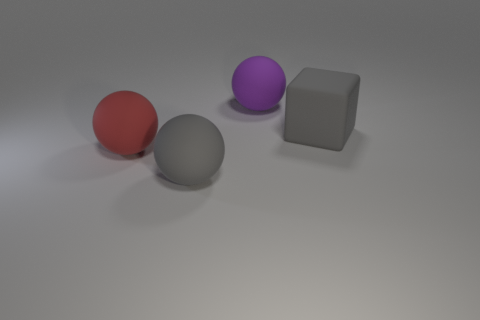What number of gray matte things have the same shape as the big red thing?
Ensure brevity in your answer.  1. The big red object is what shape?
Your answer should be very brief. Sphere. What is the size of the red ball left of the big gray matte object that is behind the big red rubber thing?
Give a very brief answer. Large. What number of things are either gray shiny cylinders or purple balls?
Ensure brevity in your answer.  1. Is the red rubber object the same shape as the large purple object?
Your response must be concise. Yes. Are there any large balls that have the same material as the purple object?
Give a very brief answer. Yes. Are there any large purple things that are to the right of the big gray rubber thing that is to the right of the purple matte sphere?
Your response must be concise. No. There is a thing that is in front of the red matte ball; is its size the same as the large rubber cube?
Your answer should be compact. Yes. The gray matte ball has what size?
Offer a very short reply. Large. Are there any things of the same color as the block?
Offer a very short reply. Yes. 